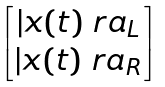Convert formula to latex. <formula><loc_0><loc_0><loc_500><loc_500>\begin{bmatrix} | x ( t ) \ r a _ { L } \\ | x ( t ) \ r a _ { R } \\ \end{bmatrix}</formula> 